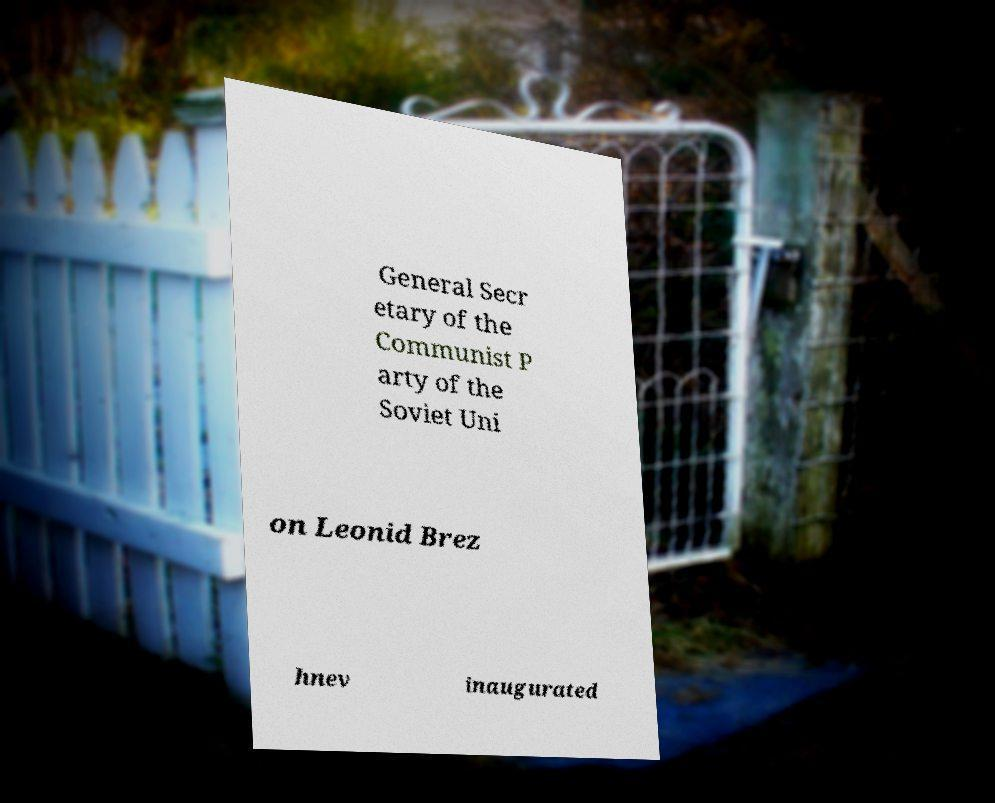Can you read and provide the text displayed in the image?This photo seems to have some interesting text. Can you extract and type it out for me? General Secr etary of the Communist P arty of the Soviet Uni on Leonid Brez hnev inaugurated 